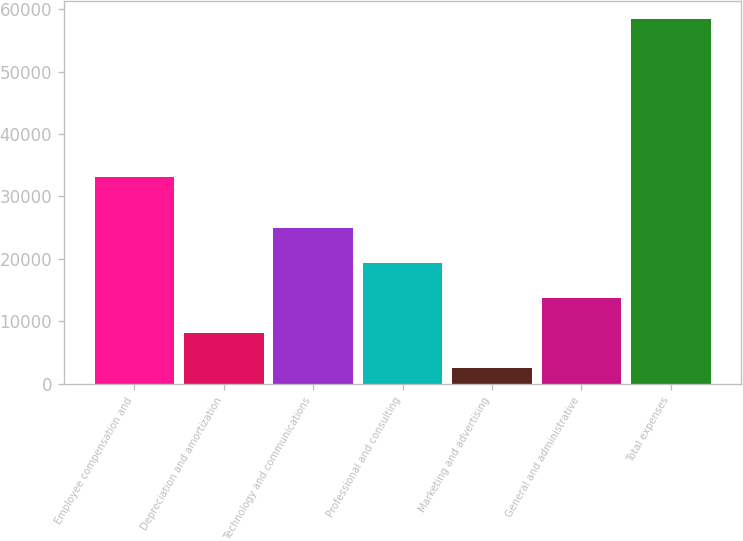Convert chart to OTSL. <chart><loc_0><loc_0><loc_500><loc_500><bar_chart><fcel>Employee compensation and<fcel>Depreciation and amortization<fcel>Technology and communications<fcel>Professional and consulting<fcel>Marketing and advertising<fcel>General and administrative<fcel>Total expenses<nl><fcel>33146<fcel>8125.1<fcel>24910.4<fcel>19315.3<fcel>2530<fcel>13720.2<fcel>58481<nl></chart> 